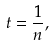Convert formula to latex. <formula><loc_0><loc_0><loc_500><loc_500>t = \frac { 1 } { n } ,</formula> 